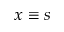Convert formula to latex. <formula><loc_0><loc_0><loc_500><loc_500>x \equiv s</formula> 